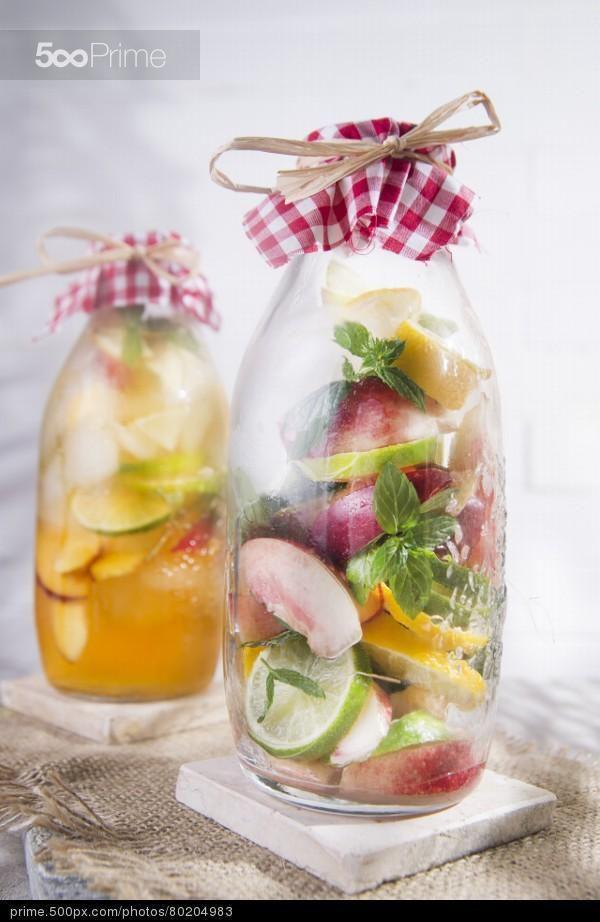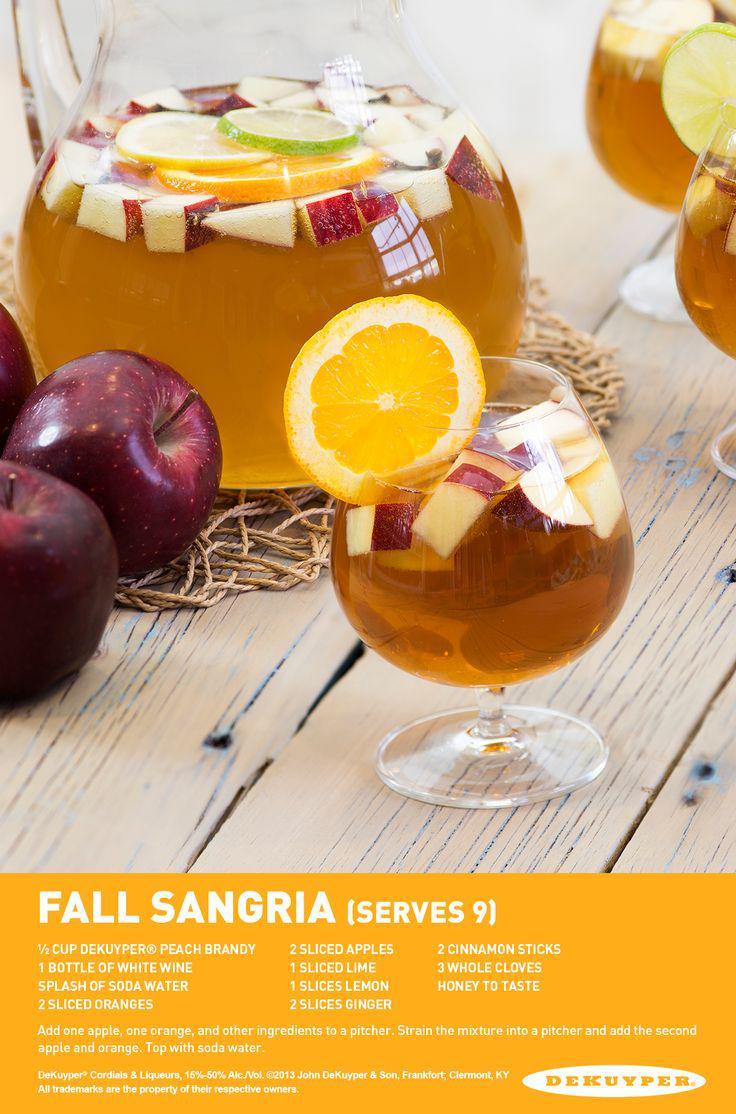The first image is the image on the left, the second image is the image on the right. Assess this claim about the two images: "A slice of citrus garnishes the drink in at least one of the images.". Correct or not? Answer yes or no. Yes. The first image is the image on the left, the second image is the image on the right. Examine the images to the left and right. Is the description "An image shows at least one glass of creamy peach-colored beverage next to peach fruit." accurate? Answer yes or no. No. 